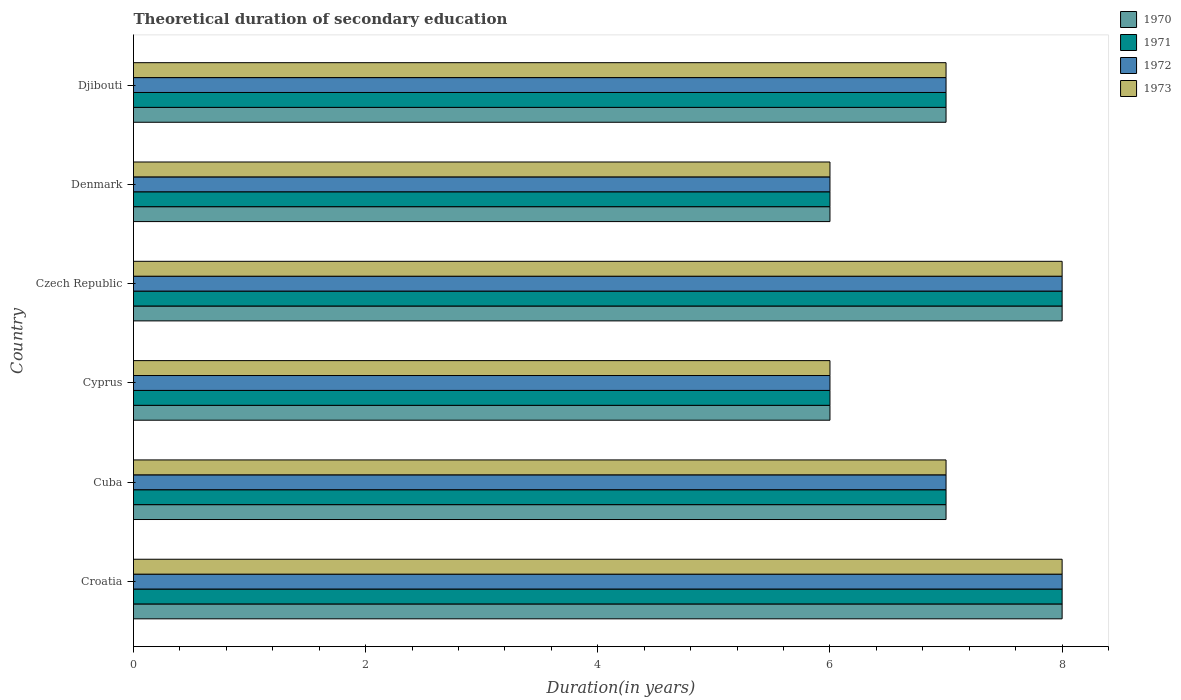How many groups of bars are there?
Keep it short and to the point. 6. Are the number of bars per tick equal to the number of legend labels?
Offer a very short reply. Yes. What is the label of the 5th group of bars from the top?
Ensure brevity in your answer.  Cuba. What is the total theoretical duration of secondary education in 1973 in Denmark?
Make the answer very short. 6. Across all countries, what is the maximum total theoretical duration of secondary education in 1971?
Provide a short and direct response. 8. Across all countries, what is the minimum total theoretical duration of secondary education in 1972?
Ensure brevity in your answer.  6. In which country was the total theoretical duration of secondary education in 1970 maximum?
Keep it short and to the point. Croatia. In which country was the total theoretical duration of secondary education in 1970 minimum?
Provide a succinct answer. Cyprus. What is the total total theoretical duration of secondary education in 1970 in the graph?
Offer a terse response. 42. What is the average total theoretical duration of secondary education in 1972 per country?
Your response must be concise. 7. In how many countries, is the total theoretical duration of secondary education in 1971 greater than 2.8 years?
Make the answer very short. 6. What is the ratio of the total theoretical duration of secondary education in 1971 in Croatia to that in Cuba?
Provide a short and direct response. 1.14. Is the total theoretical duration of secondary education in 1970 in Czech Republic less than that in Denmark?
Offer a very short reply. No. Is the difference between the total theoretical duration of secondary education in 1970 in Croatia and Czech Republic greater than the difference between the total theoretical duration of secondary education in 1973 in Croatia and Czech Republic?
Provide a short and direct response. No. What is the difference between the highest and the lowest total theoretical duration of secondary education in 1970?
Give a very brief answer. 2. What does the 2nd bar from the bottom in Cyprus represents?
Keep it short and to the point. 1971. How many bars are there?
Your answer should be very brief. 24. Does the graph contain grids?
Give a very brief answer. No. What is the title of the graph?
Your answer should be compact. Theoretical duration of secondary education. What is the label or title of the X-axis?
Make the answer very short. Duration(in years). What is the Duration(in years) in 1970 in Croatia?
Your response must be concise. 8. What is the Duration(in years) of 1972 in Croatia?
Offer a terse response. 8. What is the Duration(in years) in 1971 in Cuba?
Ensure brevity in your answer.  7. What is the Duration(in years) in 1972 in Cuba?
Your response must be concise. 7. What is the Duration(in years) in 1973 in Cuba?
Offer a terse response. 7. What is the Duration(in years) of 1971 in Cyprus?
Offer a terse response. 6. What is the Duration(in years) in 1972 in Cyprus?
Your response must be concise. 6. What is the Duration(in years) of 1973 in Cyprus?
Offer a terse response. 6. What is the Duration(in years) in 1970 in Czech Republic?
Offer a very short reply. 8. What is the Duration(in years) in 1971 in Czech Republic?
Offer a terse response. 8. What is the Duration(in years) in 1972 in Czech Republic?
Your answer should be compact. 8. What is the Duration(in years) in 1971 in Denmark?
Your answer should be compact. 6. What is the Duration(in years) in 1972 in Denmark?
Give a very brief answer. 6. What is the Duration(in years) in 1973 in Denmark?
Make the answer very short. 6. What is the Duration(in years) of 1970 in Djibouti?
Your answer should be compact. 7. What is the Duration(in years) of 1972 in Djibouti?
Keep it short and to the point. 7. What is the Duration(in years) of 1973 in Djibouti?
Make the answer very short. 7. Across all countries, what is the maximum Duration(in years) of 1971?
Keep it short and to the point. 8. Across all countries, what is the maximum Duration(in years) of 1972?
Keep it short and to the point. 8. Across all countries, what is the maximum Duration(in years) of 1973?
Your answer should be very brief. 8. Across all countries, what is the minimum Duration(in years) of 1971?
Offer a terse response. 6. What is the total Duration(in years) of 1970 in the graph?
Make the answer very short. 42. What is the total Duration(in years) of 1971 in the graph?
Offer a terse response. 42. What is the total Duration(in years) of 1972 in the graph?
Provide a short and direct response. 42. What is the difference between the Duration(in years) of 1971 in Croatia and that in Cuba?
Provide a short and direct response. 1. What is the difference between the Duration(in years) of 1972 in Croatia and that in Cuba?
Offer a terse response. 1. What is the difference between the Duration(in years) of 1970 in Croatia and that in Cyprus?
Your answer should be very brief. 2. What is the difference between the Duration(in years) in 1971 in Croatia and that in Cyprus?
Your response must be concise. 2. What is the difference between the Duration(in years) in 1972 in Croatia and that in Cyprus?
Give a very brief answer. 2. What is the difference between the Duration(in years) of 1970 in Croatia and that in Czech Republic?
Provide a short and direct response. 0. What is the difference between the Duration(in years) in 1970 in Croatia and that in Djibouti?
Make the answer very short. 1. What is the difference between the Duration(in years) in 1973 in Croatia and that in Djibouti?
Make the answer very short. 1. What is the difference between the Duration(in years) in 1972 in Cuba and that in Cyprus?
Offer a very short reply. 1. What is the difference between the Duration(in years) in 1970 in Cuba and that in Czech Republic?
Make the answer very short. -1. What is the difference between the Duration(in years) of 1971 in Cuba and that in Czech Republic?
Keep it short and to the point. -1. What is the difference between the Duration(in years) of 1973 in Cuba and that in Czech Republic?
Ensure brevity in your answer.  -1. What is the difference between the Duration(in years) of 1970 in Cuba and that in Denmark?
Ensure brevity in your answer.  1. What is the difference between the Duration(in years) in 1971 in Cuba and that in Denmark?
Provide a succinct answer. 1. What is the difference between the Duration(in years) in 1972 in Cuba and that in Denmark?
Provide a short and direct response. 1. What is the difference between the Duration(in years) of 1971 in Cuba and that in Djibouti?
Provide a short and direct response. 0. What is the difference between the Duration(in years) in 1972 in Cuba and that in Djibouti?
Keep it short and to the point. 0. What is the difference between the Duration(in years) in 1970 in Cyprus and that in Czech Republic?
Make the answer very short. -2. What is the difference between the Duration(in years) in 1972 in Cyprus and that in Czech Republic?
Your answer should be compact. -2. What is the difference between the Duration(in years) in 1972 in Cyprus and that in Denmark?
Provide a short and direct response. 0. What is the difference between the Duration(in years) of 1972 in Cyprus and that in Djibouti?
Provide a succinct answer. -1. What is the difference between the Duration(in years) in 1973 in Cyprus and that in Djibouti?
Give a very brief answer. -1. What is the difference between the Duration(in years) in 1972 in Czech Republic and that in Djibouti?
Give a very brief answer. 1. What is the difference between the Duration(in years) in 1973 in Czech Republic and that in Djibouti?
Make the answer very short. 1. What is the difference between the Duration(in years) of 1971 in Denmark and that in Djibouti?
Your answer should be very brief. -1. What is the difference between the Duration(in years) of 1973 in Denmark and that in Djibouti?
Give a very brief answer. -1. What is the difference between the Duration(in years) in 1970 in Croatia and the Duration(in years) in 1972 in Cuba?
Offer a very short reply. 1. What is the difference between the Duration(in years) in 1970 in Croatia and the Duration(in years) in 1973 in Cuba?
Your response must be concise. 1. What is the difference between the Duration(in years) of 1971 in Croatia and the Duration(in years) of 1972 in Cuba?
Your answer should be very brief. 1. What is the difference between the Duration(in years) in 1971 in Croatia and the Duration(in years) in 1973 in Cuba?
Keep it short and to the point. 1. What is the difference between the Duration(in years) of 1970 in Croatia and the Duration(in years) of 1971 in Cyprus?
Provide a short and direct response. 2. What is the difference between the Duration(in years) of 1970 in Croatia and the Duration(in years) of 1972 in Cyprus?
Keep it short and to the point. 2. What is the difference between the Duration(in years) in 1971 in Croatia and the Duration(in years) in 1972 in Cyprus?
Your answer should be very brief. 2. What is the difference between the Duration(in years) of 1971 in Croatia and the Duration(in years) of 1973 in Cyprus?
Your response must be concise. 2. What is the difference between the Duration(in years) of 1972 in Croatia and the Duration(in years) of 1973 in Cyprus?
Offer a very short reply. 2. What is the difference between the Duration(in years) of 1970 in Croatia and the Duration(in years) of 1972 in Czech Republic?
Provide a short and direct response. 0. What is the difference between the Duration(in years) of 1970 in Croatia and the Duration(in years) of 1973 in Czech Republic?
Make the answer very short. 0. What is the difference between the Duration(in years) in 1971 in Croatia and the Duration(in years) in 1973 in Czech Republic?
Offer a very short reply. 0. What is the difference between the Duration(in years) of 1972 in Croatia and the Duration(in years) of 1973 in Czech Republic?
Offer a very short reply. 0. What is the difference between the Duration(in years) in 1970 in Croatia and the Duration(in years) in 1971 in Denmark?
Offer a very short reply. 2. What is the difference between the Duration(in years) in 1971 in Croatia and the Duration(in years) in 1972 in Denmark?
Ensure brevity in your answer.  2. What is the difference between the Duration(in years) in 1972 in Croatia and the Duration(in years) in 1973 in Denmark?
Your answer should be compact. 2. What is the difference between the Duration(in years) of 1970 in Croatia and the Duration(in years) of 1971 in Djibouti?
Ensure brevity in your answer.  1. What is the difference between the Duration(in years) of 1971 in Croatia and the Duration(in years) of 1972 in Djibouti?
Offer a terse response. 1. What is the difference between the Duration(in years) in 1972 in Croatia and the Duration(in years) in 1973 in Djibouti?
Offer a terse response. 1. What is the difference between the Duration(in years) in 1970 in Cuba and the Duration(in years) in 1971 in Czech Republic?
Offer a terse response. -1. What is the difference between the Duration(in years) in 1970 in Cuba and the Duration(in years) in 1972 in Czech Republic?
Make the answer very short. -1. What is the difference between the Duration(in years) in 1970 in Cuba and the Duration(in years) in 1973 in Czech Republic?
Provide a succinct answer. -1. What is the difference between the Duration(in years) of 1971 in Cuba and the Duration(in years) of 1972 in Czech Republic?
Provide a succinct answer. -1. What is the difference between the Duration(in years) in 1972 in Cuba and the Duration(in years) in 1973 in Czech Republic?
Your answer should be compact. -1. What is the difference between the Duration(in years) of 1970 in Cuba and the Duration(in years) of 1973 in Denmark?
Ensure brevity in your answer.  1. What is the difference between the Duration(in years) in 1971 in Cuba and the Duration(in years) in 1972 in Denmark?
Your answer should be compact. 1. What is the difference between the Duration(in years) in 1970 in Cuba and the Duration(in years) in 1971 in Djibouti?
Ensure brevity in your answer.  0. What is the difference between the Duration(in years) of 1970 in Cuba and the Duration(in years) of 1973 in Djibouti?
Ensure brevity in your answer.  0. What is the difference between the Duration(in years) of 1971 in Cuba and the Duration(in years) of 1973 in Djibouti?
Your response must be concise. 0. What is the difference between the Duration(in years) in 1972 in Cuba and the Duration(in years) in 1973 in Djibouti?
Keep it short and to the point. 0. What is the difference between the Duration(in years) of 1970 in Cyprus and the Duration(in years) of 1971 in Czech Republic?
Provide a short and direct response. -2. What is the difference between the Duration(in years) in 1970 in Cyprus and the Duration(in years) in 1973 in Czech Republic?
Offer a very short reply. -2. What is the difference between the Duration(in years) of 1971 in Cyprus and the Duration(in years) of 1972 in Czech Republic?
Ensure brevity in your answer.  -2. What is the difference between the Duration(in years) in 1972 in Cyprus and the Duration(in years) in 1973 in Czech Republic?
Provide a succinct answer. -2. What is the difference between the Duration(in years) in 1970 in Cyprus and the Duration(in years) in 1971 in Denmark?
Your answer should be compact. 0. What is the difference between the Duration(in years) in 1970 in Cyprus and the Duration(in years) in 1972 in Denmark?
Make the answer very short. 0. What is the difference between the Duration(in years) of 1970 in Cyprus and the Duration(in years) of 1973 in Denmark?
Offer a terse response. 0. What is the difference between the Duration(in years) in 1971 in Cyprus and the Duration(in years) in 1972 in Denmark?
Offer a very short reply. 0. What is the difference between the Duration(in years) of 1972 in Cyprus and the Duration(in years) of 1973 in Denmark?
Your answer should be compact. 0. What is the difference between the Duration(in years) in 1970 in Cyprus and the Duration(in years) in 1971 in Djibouti?
Your response must be concise. -1. What is the difference between the Duration(in years) of 1971 in Cyprus and the Duration(in years) of 1973 in Djibouti?
Keep it short and to the point. -1. What is the difference between the Duration(in years) in 1972 in Cyprus and the Duration(in years) in 1973 in Djibouti?
Offer a terse response. -1. What is the difference between the Duration(in years) of 1970 in Czech Republic and the Duration(in years) of 1971 in Denmark?
Make the answer very short. 2. What is the difference between the Duration(in years) of 1970 in Czech Republic and the Duration(in years) of 1972 in Denmark?
Keep it short and to the point. 2. What is the difference between the Duration(in years) of 1971 in Czech Republic and the Duration(in years) of 1973 in Denmark?
Make the answer very short. 2. What is the difference between the Duration(in years) in 1970 in Czech Republic and the Duration(in years) in 1972 in Djibouti?
Offer a terse response. 1. What is the difference between the Duration(in years) in 1970 in Czech Republic and the Duration(in years) in 1973 in Djibouti?
Give a very brief answer. 1. What is the difference between the Duration(in years) of 1971 in Czech Republic and the Duration(in years) of 1973 in Djibouti?
Give a very brief answer. 1. What is the difference between the Duration(in years) of 1970 in Denmark and the Duration(in years) of 1971 in Djibouti?
Provide a short and direct response. -1. What is the difference between the Duration(in years) of 1971 in Denmark and the Duration(in years) of 1973 in Djibouti?
Make the answer very short. -1. What is the difference between the Duration(in years) in 1972 in Denmark and the Duration(in years) in 1973 in Djibouti?
Your answer should be compact. -1. What is the average Duration(in years) of 1970 per country?
Give a very brief answer. 7. What is the average Duration(in years) in 1972 per country?
Ensure brevity in your answer.  7. What is the difference between the Duration(in years) of 1970 and Duration(in years) of 1971 in Croatia?
Provide a short and direct response. 0. What is the difference between the Duration(in years) in 1972 and Duration(in years) in 1973 in Croatia?
Keep it short and to the point. 0. What is the difference between the Duration(in years) of 1970 and Duration(in years) of 1971 in Cyprus?
Offer a terse response. 0. What is the difference between the Duration(in years) of 1970 and Duration(in years) of 1973 in Cyprus?
Make the answer very short. 0. What is the difference between the Duration(in years) in 1971 and Duration(in years) in 1973 in Cyprus?
Provide a succinct answer. 0. What is the difference between the Duration(in years) in 1972 and Duration(in years) in 1973 in Cyprus?
Provide a short and direct response. 0. What is the difference between the Duration(in years) in 1970 and Duration(in years) in 1972 in Czech Republic?
Make the answer very short. 0. What is the difference between the Duration(in years) of 1971 and Duration(in years) of 1972 in Czech Republic?
Your answer should be very brief. 0. What is the difference between the Duration(in years) in 1972 and Duration(in years) in 1973 in Czech Republic?
Provide a short and direct response. 0. What is the difference between the Duration(in years) of 1970 and Duration(in years) of 1971 in Denmark?
Your answer should be compact. 0. What is the difference between the Duration(in years) in 1970 and Duration(in years) in 1972 in Denmark?
Your answer should be very brief. 0. What is the difference between the Duration(in years) in 1971 and Duration(in years) in 1972 in Denmark?
Your answer should be compact. 0. What is the difference between the Duration(in years) of 1971 and Duration(in years) of 1973 in Denmark?
Keep it short and to the point. 0. What is the difference between the Duration(in years) in 1972 and Duration(in years) in 1973 in Denmark?
Make the answer very short. 0. What is the difference between the Duration(in years) in 1971 and Duration(in years) in 1972 in Djibouti?
Offer a very short reply. 0. What is the difference between the Duration(in years) of 1971 and Duration(in years) of 1973 in Djibouti?
Your answer should be very brief. 0. What is the ratio of the Duration(in years) of 1970 in Croatia to that in Cuba?
Offer a terse response. 1.14. What is the ratio of the Duration(in years) in 1972 in Croatia to that in Cuba?
Keep it short and to the point. 1.14. What is the ratio of the Duration(in years) of 1973 in Croatia to that in Cuba?
Offer a very short reply. 1.14. What is the ratio of the Duration(in years) of 1971 in Croatia to that in Czech Republic?
Offer a very short reply. 1. What is the ratio of the Duration(in years) in 1972 in Croatia to that in Czech Republic?
Your answer should be compact. 1. What is the ratio of the Duration(in years) of 1973 in Croatia to that in Czech Republic?
Offer a terse response. 1. What is the ratio of the Duration(in years) of 1971 in Croatia to that in Denmark?
Ensure brevity in your answer.  1.33. What is the ratio of the Duration(in years) in 1973 in Croatia to that in Denmark?
Your response must be concise. 1.33. What is the ratio of the Duration(in years) in 1971 in Croatia to that in Djibouti?
Make the answer very short. 1.14. What is the ratio of the Duration(in years) in 1970 in Cuba to that in Czech Republic?
Your response must be concise. 0.88. What is the ratio of the Duration(in years) of 1972 in Cuba to that in Denmark?
Give a very brief answer. 1.17. What is the ratio of the Duration(in years) in 1970 in Cuba to that in Djibouti?
Offer a terse response. 1. What is the ratio of the Duration(in years) in 1972 in Cuba to that in Djibouti?
Give a very brief answer. 1. What is the ratio of the Duration(in years) of 1973 in Cuba to that in Djibouti?
Offer a terse response. 1. What is the ratio of the Duration(in years) of 1970 in Cyprus to that in Czech Republic?
Provide a short and direct response. 0.75. What is the ratio of the Duration(in years) in 1972 in Cyprus to that in Czech Republic?
Ensure brevity in your answer.  0.75. What is the ratio of the Duration(in years) of 1973 in Cyprus to that in Czech Republic?
Offer a very short reply. 0.75. What is the ratio of the Duration(in years) of 1970 in Cyprus to that in Denmark?
Ensure brevity in your answer.  1. What is the ratio of the Duration(in years) of 1973 in Cyprus to that in Denmark?
Your response must be concise. 1. What is the ratio of the Duration(in years) of 1970 in Cyprus to that in Djibouti?
Offer a terse response. 0.86. What is the ratio of the Duration(in years) in 1971 in Cyprus to that in Djibouti?
Your answer should be compact. 0.86. What is the ratio of the Duration(in years) in 1973 in Cyprus to that in Djibouti?
Make the answer very short. 0.86. What is the ratio of the Duration(in years) in 1971 in Czech Republic to that in Djibouti?
Make the answer very short. 1.14. What is the ratio of the Duration(in years) in 1973 in Czech Republic to that in Djibouti?
Keep it short and to the point. 1.14. What is the ratio of the Duration(in years) of 1972 in Denmark to that in Djibouti?
Your response must be concise. 0.86. What is the difference between the highest and the second highest Duration(in years) in 1970?
Ensure brevity in your answer.  0. What is the difference between the highest and the lowest Duration(in years) in 1972?
Keep it short and to the point. 2. What is the difference between the highest and the lowest Duration(in years) in 1973?
Make the answer very short. 2. 